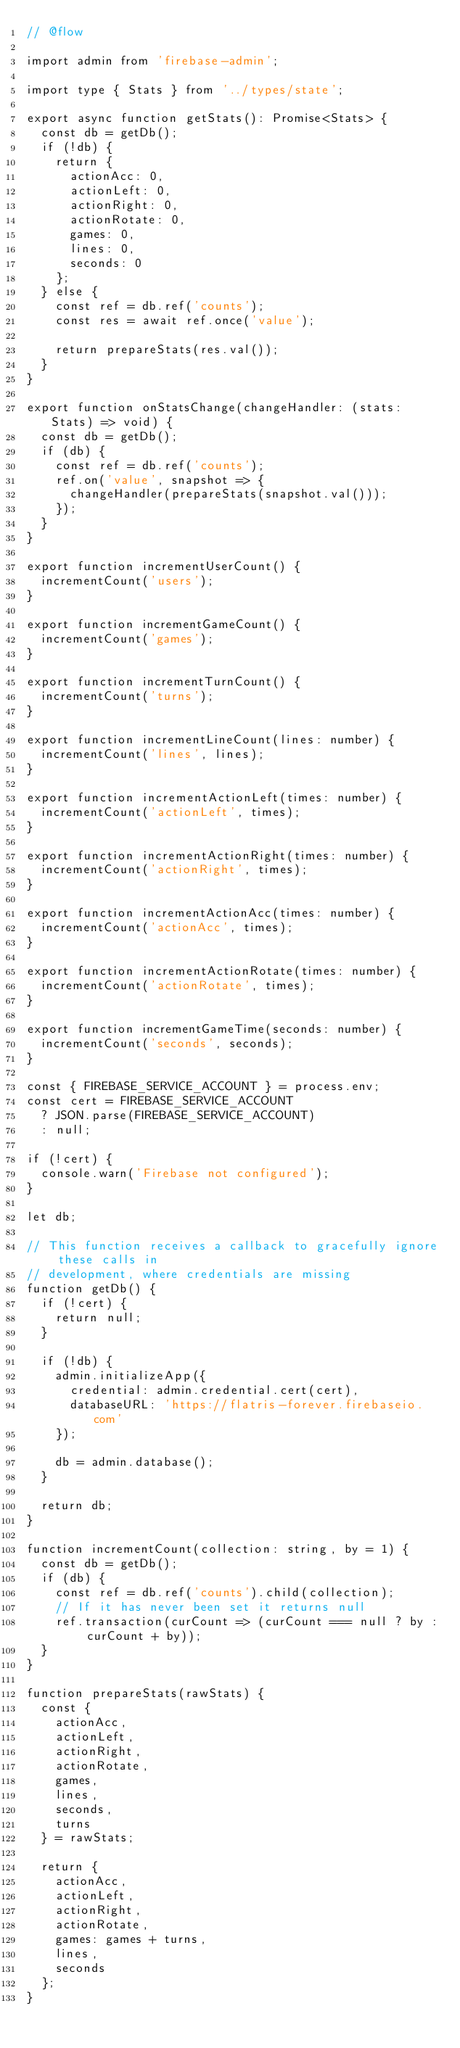<code> <loc_0><loc_0><loc_500><loc_500><_JavaScript_>// @flow

import admin from 'firebase-admin';

import type { Stats } from '../types/state';

export async function getStats(): Promise<Stats> {
  const db = getDb();
  if (!db) {
    return {
      actionAcc: 0,
      actionLeft: 0,
      actionRight: 0,
      actionRotate: 0,
      games: 0,
      lines: 0,
      seconds: 0
    };
  } else {
    const ref = db.ref('counts');
    const res = await ref.once('value');

    return prepareStats(res.val());
  }
}

export function onStatsChange(changeHandler: (stats: Stats) => void) {
  const db = getDb();
  if (db) {
    const ref = db.ref('counts');
    ref.on('value', snapshot => {
      changeHandler(prepareStats(snapshot.val()));
    });
  }
}

export function incrementUserCount() {
  incrementCount('users');
}

export function incrementGameCount() {
  incrementCount('games');
}

export function incrementTurnCount() {
  incrementCount('turns');
}

export function incrementLineCount(lines: number) {
  incrementCount('lines', lines);
}

export function incrementActionLeft(times: number) {
  incrementCount('actionLeft', times);
}

export function incrementActionRight(times: number) {
  incrementCount('actionRight', times);
}

export function incrementActionAcc(times: number) {
  incrementCount('actionAcc', times);
}

export function incrementActionRotate(times: number) {
  incrementCount('actionRotate', times);
}

export function incrementGameTime(seconds: number) {
  incrementCount('seconds', seconds);
}

const { FIREBASE_SERVICE_ACCOUNT } = process.env;
const cert = FIREBASE_SERVICE_ACCOUNT
  ? JSON.parse(FIREBASE_SERVICE_ACCOUNT)
  : null;

if (!cert) {
  console.warn('Firebase not configured');
}

let db;

// This function receives a callback to gracefully ignore these calls in
// development, where credentials are missing
function getDb() {
  if (!cert) {
    return null;
  }

  if (!db) {
    admin.initializeApp({
      credential: admin.credential.cert(cert),
      databaseURL: 'https://flatris-forever.firebaseio.com'
    });

    db = admin.database();
  }

  return db;
}

function incrementCount(collection: string, by = 1) {
  const db = getDb();
  if (db) {
    const ref = db.ref('counts').child(collection);
    // If it has never been set it returns null
    ref.transaction(curCount => (curCount === null ? by : curCount + by));
  }
}

function prepareStats(rawStats) {
  const {
    actionAcc,
    actionLeft,
    actionRight,
    actionRotate,
    games,
    lines,
    seconds,
    turns
  } = rawStats;

  return {
    actionAcc,
    actionLeft,
    actionRight,
    actionRotate,
    games: games + turns,
    lines,
    seconds
  };
}
</code> 